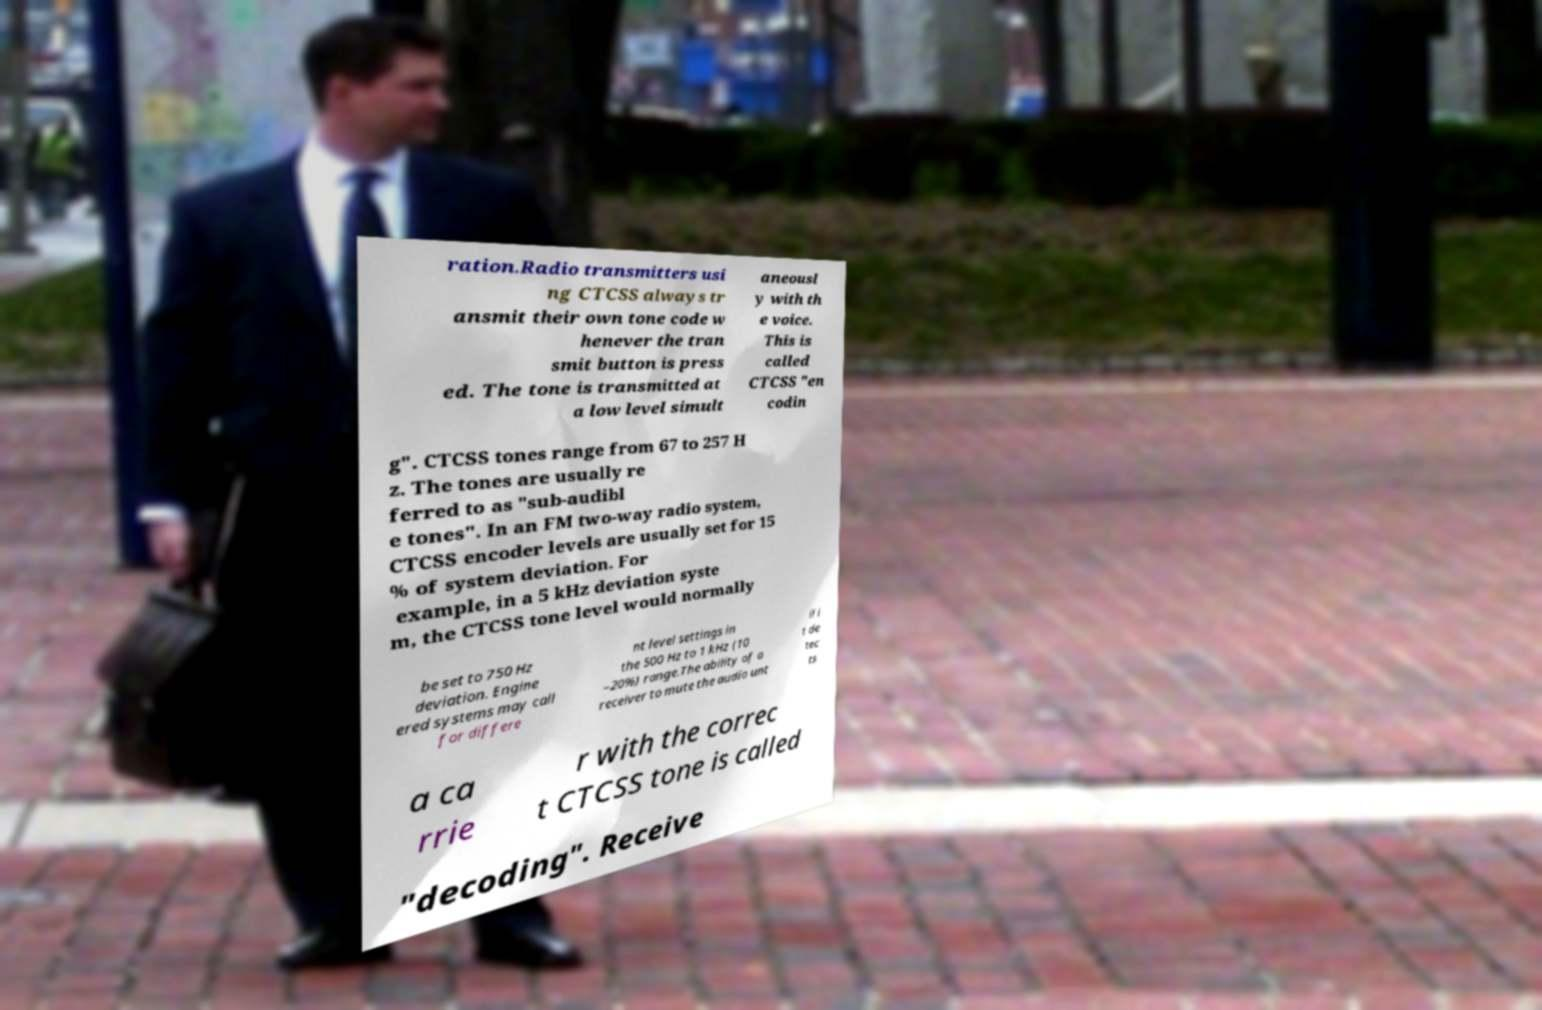There's text embedded in this image that I need extracted. Can you transcribe it verbatim? ration.Radio transmitters usi ng CTCSS always tr ansmit their own tone code w henever the tran smit button is press ed. The tone is transmitted at a low level simult aneousl y with th e voice. This is called CTCSS "en codin g". CTCSS tones range from 67 to 257 H z. The tones are usually re ferred to as "sub-audibl e tones". In an FM two-way radio system, CTCSS encoder levels are usually set for 15 % of system deviation. For example, in a 5 kHz deviation syste m, the CTCSS tone level would normally be set to 750 Hz deviation. Engine ered systems may call for differe nt level settings in the 500 Hz to 1 kHz (10 –20%) range.The ability of a receiver to mute the audio unt il i t de tec ts a ca rrie r with the correc t CTCSS tone is called "decoding". Receive 